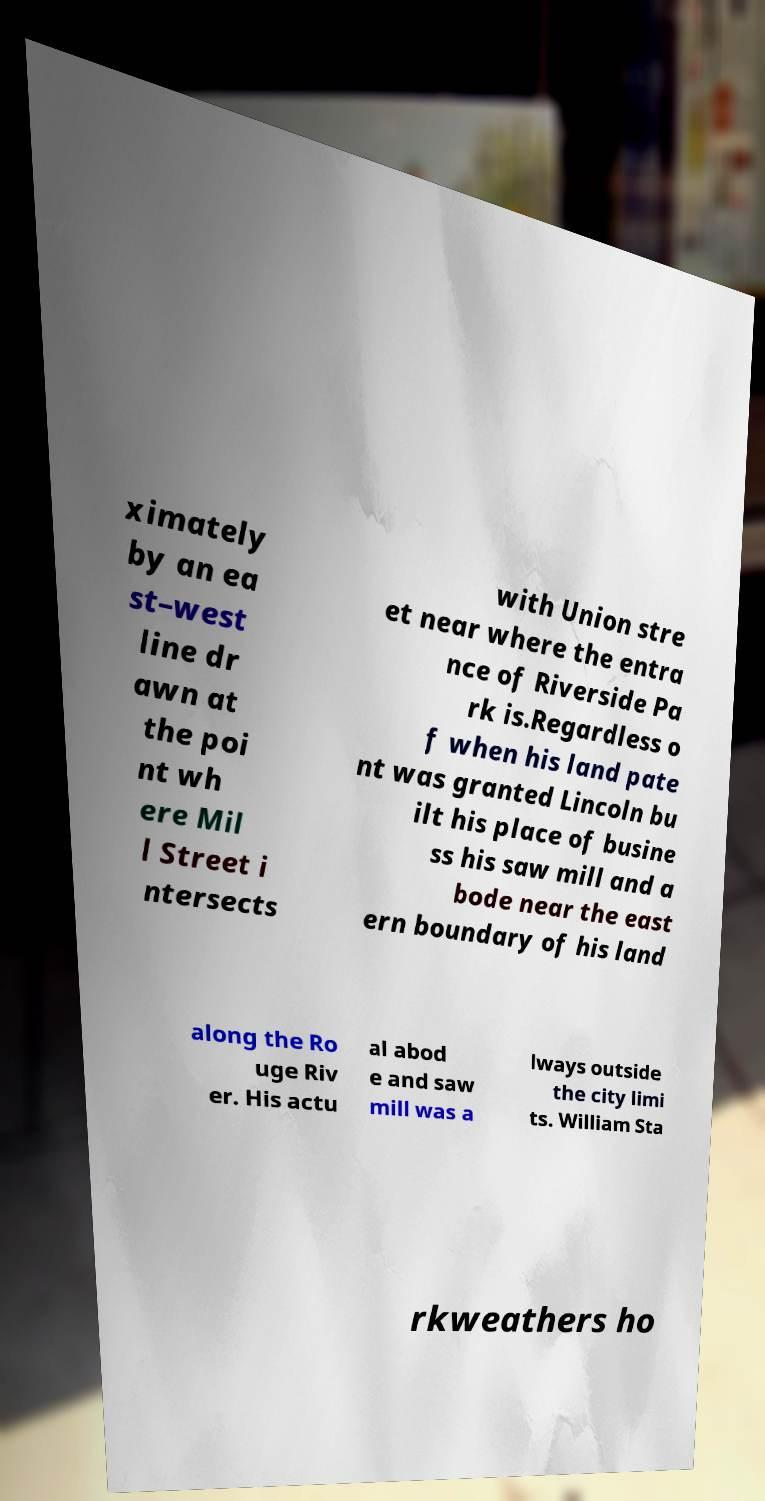For documentation purposes, I need the text within this image transcribed. Could you provide that? ximately by an ea st–west line dr awn at the poi nt wh ere Mil l Street i ntersects with Union stre et near where the entra nce of Riverside Pa rk is.Regardless o f when his land pate nt was granted Lincoln bu ilt his place of busine ss his saw mill and a bode near the east ern boundary of his land along the Ro uge Riv er. His actu al abod e and saw mill was a lways outside the city limi ts. William Sta rkweathers ho 